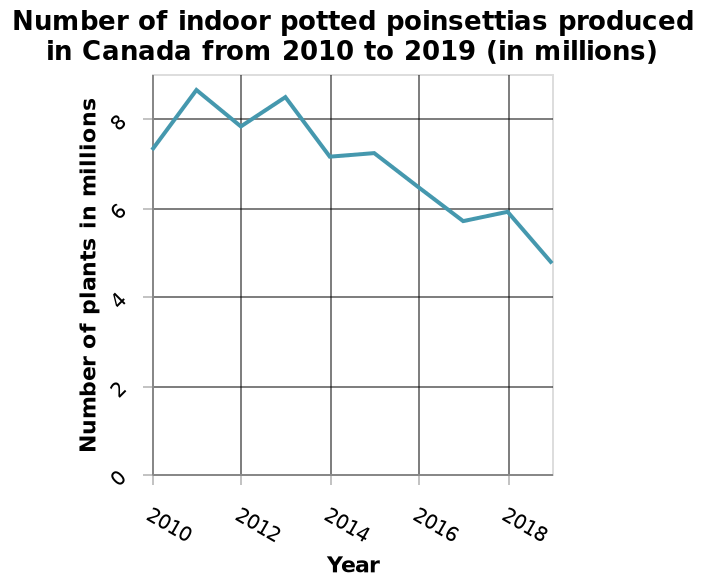<image>
Has the production of indoor potted poinsettias in Canada been consistent over the years?  No, there has been a decline in the production of indoor potted poinsettias in Canada from 2010 to 2019. Offer a thorough analysis of the image. The graph shows that there has been a decline in the number of indoor potted poinsettias produced in Canada from 2010 to 2019. The highest number was in 2011 and the lowest number was in 2019. please enumerates aspects of the construction of the chart Number of indoor potted poinsettias produced in Canada from 2010 to 2019 (in millions) is a line chart. Year is plotted along the x-axis. A linear scale of range 0 to 8 can be seen along the y-axis, labeled Number of plants in millions. What is the highest number of indoor potted poinsettias produced in a single year during the given period? The line chart does not provide the exact value for the highest number produced, but the highest point on the chart can be visually identified to determine the approximate value. 